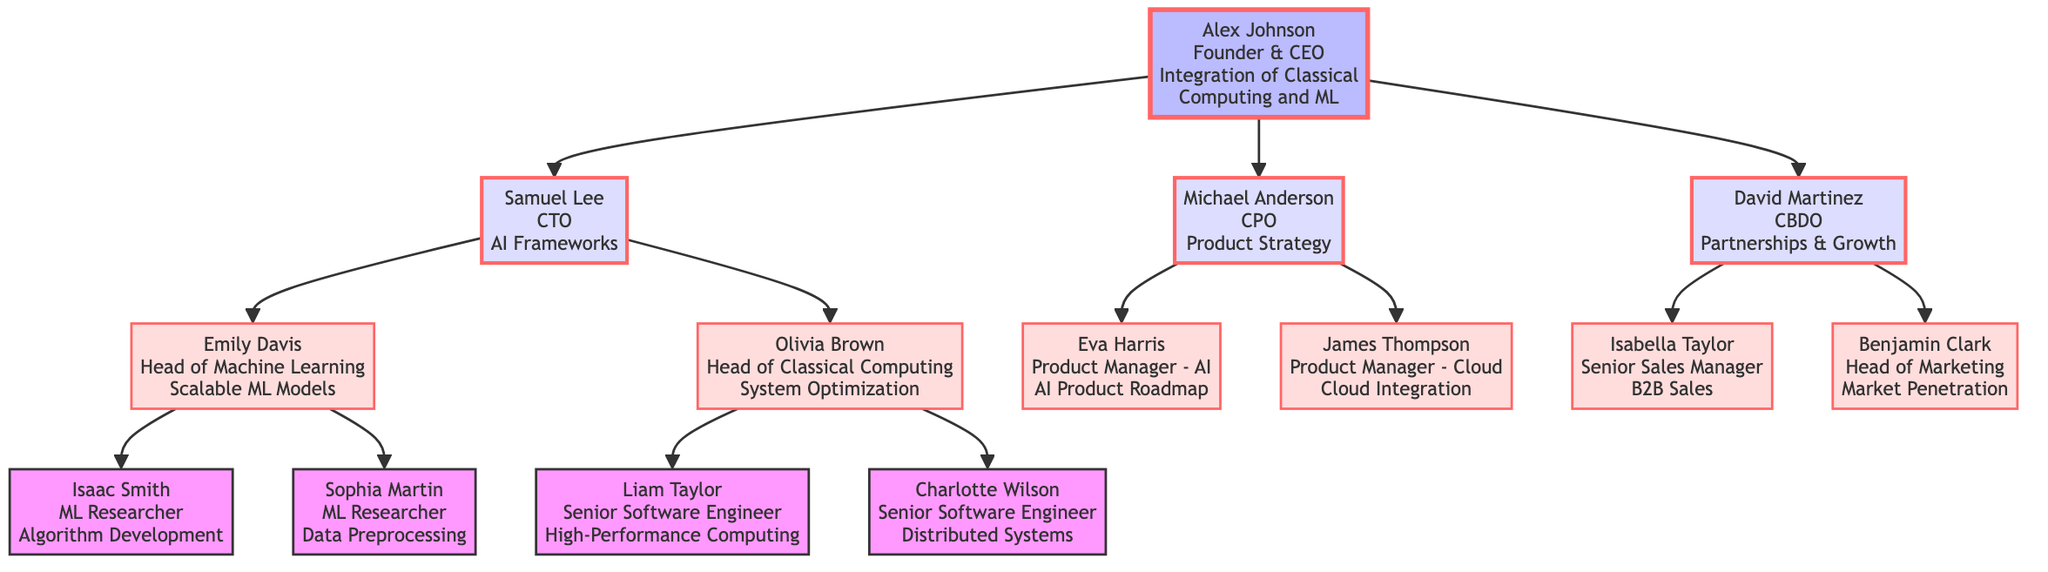What is the title of the founder? The title of the founder is directly listed as "Founder & CEO" in the diagram.
Answer: Founder & CEO How many direct reports does the CTO have? The CTO has two direct reports: the Head of Machine Learning and the Head of Classical Computing, which can be counted off the branches directly connected to the TechLead node.
Answer: 2 Who specializes in "Data Preprocessing"? The specialization "Data Preprocessing" is associated with the node "Sophia Martin," who is a Machine Learning Researcher under the MLTeamLead.
Answer: Sophia Martin Which team focuses on AI Frameworks? The team that focuses on AI Frameworks is led by Samuel Lee, who is the Chief Technical Officer. This is indicated by the direct connection from the Founder to the TechLead node.
Answer: Samuel Lee What role does Liam Taylor have? Liam Taylor's role is specifically mentioned as "Senior Software Engineer." This information can be located under the ClassicalCompLead node in the diagram.
Answer: Senior Software Engineer Who reports directly to the Chief Product Officer? The Chief Product Officer, Michael Anderson, has two direct reports listed as Product Manager - AI and Product Manager - Cloud. These roles branch from the ProductManager node.
Answer: Eva Harris and James Thompson Which node has the specialization "Market Penetration"? "Market Penetration" is the specialization of Benjamin Clark, who is the Head of Marketing. This is indicated under the BizDevLead node.
Answer: Benjamin Clark How many Machine Learning Researchers are there? There are two Machine Learning Researchers: Isaac Smith and Sophia Martin. This count can be observed under the MLTeamLead's team in the structure.
Answer: 2 Who is responsible for "B2B Sales"? The responsibility for "B2B Sales" lies with Isabella Taylor, who is the Senior Sales Manager. This information can be traced from the BizDevLead's team structure.
Answer: Isabella Taylor 